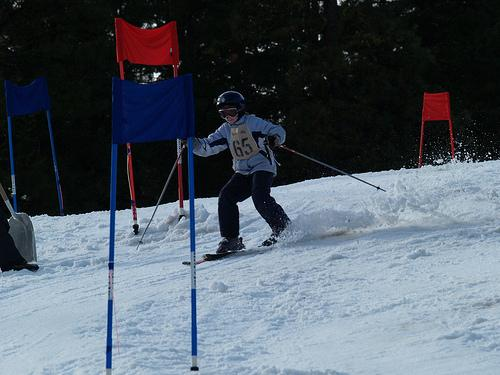Describe the main action occurring in the image while also providing context. A competitor, wearing a blue coat and black ski pants, is skiing downhill in a children's ski competition with number 65 on their bib and red and blue course markers surrounding them. In your own words, describe the main focus of the image. The image highlights a young skier, dressed in a blue coat and black pants, rapidly descending a snowy mountain amidst a kids' skiing competition. What are the notable environmental features of the image? The skiing course is set amidst evergreen trees, with red and blue flags marking the track and snow flying in the air. Provide a brief overview of the scene captured in the image. A young skier with number 65, wearing a blue coat, black pants, and protective gear, is skiing downhill in a competition with red and blue markers. Summarize the overall theme of the image in a sentence. A young ski competitor navigates a snowy, flagged track wearing protective gear and displaying the number 65. Detail the visible pieces of equipment and gear associated with the main subject's activity. The young skier is equipped with a helmet, goggles, skiing poles, gloves, skis, and a number tag displaying 65. Describe the setting of the image and the main action taking place. The scene takes place on a skiing course with red and blue flags, where a young competitor wearing number 65 is skiing downhill. Imagine you're describing the scene to a friend. What key details would you mention? There's this picture of a child skiing in a competition with a number 65 tag, wearing a blue coat and protective gear, surrounded by red and blue flags on the track. Mention the attire worn by the main subject in the image and their activity. A child wearing a blue coat, black ski pants, a helmet, and goggles is skiing down a snowy slope in a competition. What is the most striking aspect of the image, and how does it relate to the primary subject? The most striking aspect of the image is the young skier's enthusiastic descent amidst a colorful, flagged skiing course in a children's competition. There are two skiers wearing yellow jackets racing against each other on the course. There is no mention of yellow jackets or multiple skiers racing in the image. There is a large pink umbrella held by someone in the background. No, it's not mentioned in the image. Can you find the snowboarder wearing a green helmet in the image? There is no snowboarder mentioned, only skiers; and there is no green helmet mentioned, only a black one. Can you see a bright orange snowmobile parked near the trees? There is no mention of a snowmobile or anything orange in the image. Can you spot an orange and white race flag waving at the finish line? There are no orange and white race flags mentioned in the image, only red and blue ones. Search for the girl skiing with her pet dog on the snowy slope. Although the image has skiers, there is no mention of a girl skiing with a pet dog. A snowman with a carrot nose and a blue hat is present in the image. There is no mention of a snowman or any related attributes like a carrot nose or blue hat. Find a group of people gathered around a campfire near the ski course. There is no mention of a campfire or a group of people in the image. 